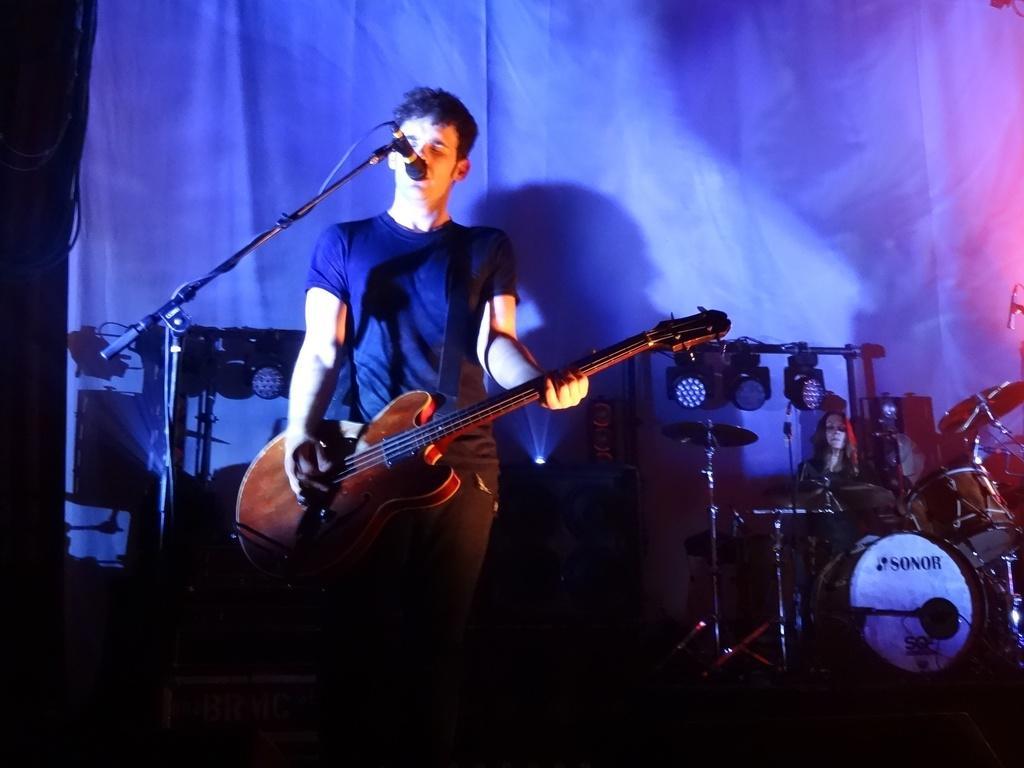Please provide a concise description of this image. Man is singing and playing a guitar. In front of him there is a mic and mic stands. In the background there is drum. Woman is playing it. There are lights in the background also there is a curtain. 